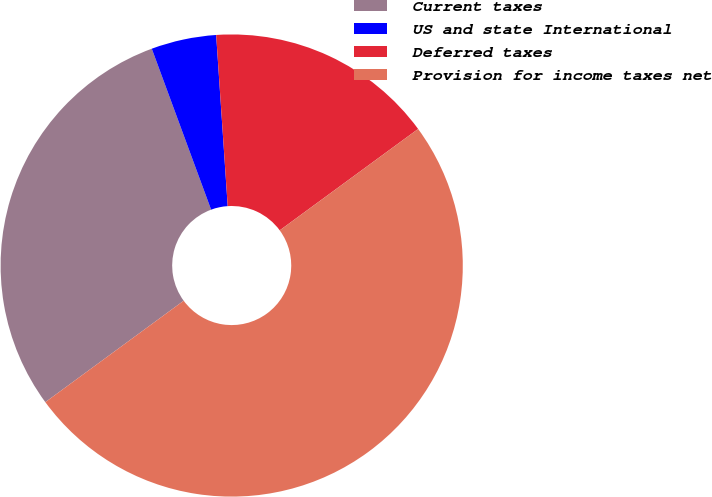Convert chart. <chart><loc_0><loc_0><loc_500><loc_500><pie_chart><fcel>Current taxes<fcel>US and state International<fcel>Deferred taxes<fcel>Provision for income taxes net<nl><fcel>29.45%<fcel>4.55%<fcel>16.01%<fcel>50.0%<nl></chart> 